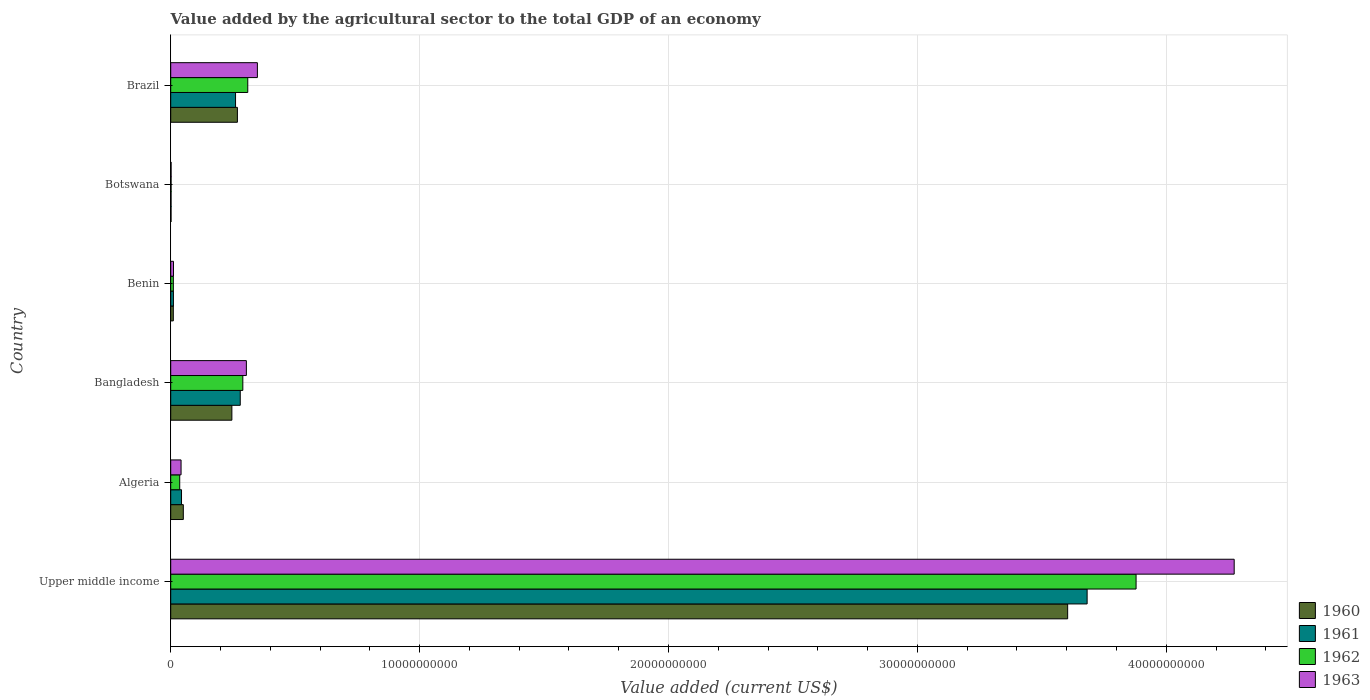How many different coloured bars are there?
Your answer should be very brief. 4. Are the number of bars on each tick of the Y-axis equal?
Keep it short and to the point. Yes. How many bars are there on the 6th tick from the top?
Your answer should be very brief. 4. How many bars are there on the 3rd tick from the bottom?
Give a very brief answer. 4. What is the label of the 5th group of bars from the top?
Your answer should be compact. Algeria. In how many cases, is the number of bars for a given country not equal to the number of legend labels?
Your answer should be compact. 0. What is the value added by the agricultural sector to the total GDP in 1960 in Benin?
Give a very brief answer. 1.04e+08. Across all countries, what is the maximum value added by the agricultural sector to the total GDP in 1963?
Offer a very short reply. 4.27e+1. Across all countries, what is the minimum value added by the agricultural sector to the total GDP in 1963?
Make the answer very short. 1.51e+07. In which country was the value added by the agricultural sector to the total GDP in 1963 maximum?
Provide a short and direct response. Upper middle income. In which country was the value added by the agricultural sector to the total GDP in 1960 minimum?
Give a very brief answer. Botswana. What is the total value added by the agricultural sector to the total GDP in 1961 in the graph?
Offer a very short reply. 4.28e+1. What is the difference between the value added by the agricultural sector to the total GDP in 1961 in Algeria and that in Brazil?
Give a very brief answer. -2.17e+09. What is the difference between the value added by the agricultural sector to the total GDP in 1960 in Brazil and the value added by the agricultural sector to the total GDP in 1961 in Benin?
Your answer should be compact. 2.57e+09. What is the average value added by the agricultural sector to the total GDP in 1961 per country?
Keep it short and to the point. 7.13e+09. What is the difference between the value added by the agricultural sector to the total GDP in 1961 and value added by the agricultural sector to the total GDP in 1962 in Brazil?
Offer a very short reply. -4.91e+08. In how many countries, is the value added by the agricultural sector to the total GDP in 1963 greater than 22000000000 US$?
Your answer should be very brief. 1. What is the ratio of the value added by the agricultural sector to the total GDP in 1961 in Brazil to that in Upper middle income?
Keep it short and to the point. 0.07. What is the difference between the highest and the second highest value added by the agricultural sector to the total GDP in 1960?
Provide a short and direct response. 3.34e+1. What is the difference between the highest and the lowest value added by the agricultural sector to the total GDP in 1962?
Make the answer very short. 3.88e+1. Is the sum of the value added by the agricultural sector to the total GDP in 1963 in Algeria and Brazil greater than the maximum value added by the agricultural sector to the total GDP in 1960 across all countries?
Your answer should be compact. No. Is it the case that in every country, the sum of the value added by the agricultural sector to the total GDP in 1960 and value added by the agricultural sector to the total GDP in 1962 is greater than the sum of value added by the agricultural sector to the total GDP in 1963 and value added by the agricultural sector to the total GDP in 1961?
Keep it short and to the point. No. What does the 3rd bar from the top in Algeria represents?
Provide a succinct answer. 1961. How many bars are there?
Provide a short and direct response. 24. Are all the bars in the graph horizontal?
Your answer should be compact. Yes. Does the graph contain any zero values?
Your response must be concise. No. How are the legend labels stacked?
Provide a short and direct response. Vertical. What is the title of the graph?
Your answer should be compact. Value added by the agricultural sector to the total GDP of an economy. Does "1980" appear as one of the legend labels in the graph?
Make the answer very short. No. What is the label or title of the X-axis?
Provide a short and direct response. Value added (current US$). What is the Value added (current US$) in 1960 in Upper middle income?
Provide a short and direct response. 3.60e+1. What is the Value added (current US$) in 1961 in Upper middle income?
Your response must be concise. 3.68e+1. What is the Value added (current US$) of 1962 in Upper middle income?
Keep it short and to the point. 3.88e+1. What is the Value added (current US$) in 1963 in Upper middle income?
Keep it short and to the point. 4.27e+1. What is the Value added (current US$) of 1960 in Algeria?
Ensure brevity in your answer.  5.06e+08. What is the Value added (current US$) in 1961 in Algeria?
Ensure brevity in your answer.  4.34e+08. What is the Value added (current US$) in 1962 in Algeria?
Offer a very short reply. 3.61e+08. What is the Value added (current US$) of 1963 in Algeria?
Provide a succinct answer. 4.16e+08. What is the Value added (current US$) of 1960 in Bangladesh?
Your answer should be very brief. 2.46e+09. What is the Value added (current US$) in 1961 in Bangladesh?
Provide a succinct answer. 2.79e+09. What is the Value added (current US$) in 1962 in Bangladesh?
Provide a short and direct response. 2.90e+09. What is the Value added (current US$) in 1963 in Bangladesh?
Make the answer very short. 3.04e+09. What is the Value added (current US$) of 1960 in Benin?
Offer a very short reply. 1.04e+08. What is the Value added (current US$) in 1961 in Benin?
Keep it short and to the point. 1.09e+08. What is the Value added (current US$) in 1962 in Benin?
Your answer should be very brief. 1.06e+08. What is the Value added (current US$) in 1963 in Benin?
Give a very brief answer. 1.11e+08. What is the Value added (current US$) in 1960 in Botswana?
Provide a short and direct response. 1.31e+07. What is the Value added (current US$) of 1961 in Botswana?
Make the answer very short. 1.38e+07. What is the Value added (current US$) of 1962 in Botswana?
Provide a succinct answer. 1.45e+07. What is the Value added (current US$) of 1963 in Botswana?
Your answer should be compact. 1.51e+07. What is the Value added (current US$) of 1960 in Brazil?
Keep it short and to the point. 2.68e+09. What is the Value added (current US$) of 1961 in Brazil?
Give a very brief answer. 2.60e+09. What is the Value added (current US$) of 1962 in Brazil?
Your response must be concise. 3.10e+09. What is the Value added (current US$) in 1963 in Brazil?
Provide a succinct answer. 3.48e+09. Across all countries, what is the maximum Value added (current US$) of 1960?
Make the answer very short. 3.60e+1. Across all countries, what is the maximum Value added (current US$) of 1961?
Your answer should be very brief. 3.68e+1. Across all countries, what is the maximum Value added (current US$) of 1962?
Ensure brevity in your answer.  3.88e+1. Across all countries, what is the maximum Value added (current US$) of 1963?
Offer a terse response. 4.27e+1. Across all countries, what is the minimum Value added (current US$) in 1960?
Offer a terse response. 1.31e+07. Across all countries, what is the minimum Value added (current US$) in 1961?
Offer a very short reply. 1.38e+07. Across all countries, what is the minimum Value added (current US$) in 1962?
Your answer should be compact. 1.45e+07. Across all countries, what is the minimum Value added (current US$) of 1963?
Keep it short and to the point. 1.51e+07. What is the total Value added (current US$) of 1960 in the graph?
Offer a terse response. 4.18e+1. What is the total Value added (current US$) in 1961 in the graph?
Offer a terse response. 4.28e+1. What is the total Value added (current US$) in 1962 in the graph?
Keep it short and to the point. 4.53e+1. What is the total Value added (current US$) in 1963 in the graph?
Ensure brevity in your answer.  4.98e+1. What is the difference between the Value added (current US$) in 1960 in Upper middle income and that in Algeria?
Offer a very short reply. 3.55e+1. What is the difference between the Value added (current US$) in 1961 in Upper middle income and that in Algeria?
Provide a short and direct response. 3.64e+1. What is the difference between the Value added (current US$) in 1962 in Upper middle income and that in Algeria?
Provide a succinct answer. 3.84e+1. What is the difference between the Value added (current US$) in 1963 in Upper middle income and that in Algeria?
Provide a short and direct response. 4.23e+1. What is the difference between the Value added (current US$) in 1960 in Upper middle income and that in Bangladesh?
Ensure brevity in your answer.  3.36e+1. What is the difference between the Value added (current US$) of 1961 in Upper middle income and that in Bangladesh?
Offer a terse response. 3.40e+1. What is the difference between the Value added (current US$) of 1962 in Upper middle income and that in Bangladesh?
Provide a short and direct response. 3.59e+1. What is the difference between the Value added (current US$) in 1963 in Upper middle income and that in Bangladesh?
Ensure brevity in your answer.  3.97e+1. What is the difference between the Value added (current US$) in 1960 in Upper middle income and that in Benin?
Your answer should be very brief. 3.59e+1. What is the difference between the Value added (current US$) in 1961 in Upper middle income and that in Benin?
Offer a terse response. 3.67e+1. What is the difference between the Value added (current US$) of 1962 in Upper middle income and that in Benin?
Provide a succinct answer. 3.87e+1. What is the difference between the Value added (current US$) of 1963 in Upper middle income and that in Benin?
Provide a succinct answer. 4.26e+1. What is the difference between the Value added (current US$) in 1960 in Upper middle income and that in Botswana?
Keep it short and to the point. 3.60e+1. What is the difference between the Value added (current US$) of 1961 in Upper middle income and that in Botswana?
Your answer should be very brief. 3.68e+1. What is the difference between the Value added (current US$) in 1962 in Upper middle income and that in Botswana?
Make the answer very short. 3.88e+1. What is the difference between the Value added (current US$) of 1963 in Upper middle income and that in Botswana?
Your answer should be very brief. 4.27e+1. What is the difference between the Value added (current US$) of 1960 in Upper middle income and that in Brazil?
Keep it short and to the point. 3.34e+1. What is the difference between the Value added (current US$) of 1961 in Upper middle income and that in Brazil?
Your response must be concise. 3.42e+1. What is the difference between the Value added (current US$) of 1962 in Upper middle income and that in Brazil?
Give a very brief answer. 3.57e+1. What is the difference between the Value added (current US$) of 1963 in Upper middle income and that in Brazil?
Offer a very short reply. 3.92e+1. What is the difference between the Value added (current US$) in 1960 in Algeria and that in Bangladesh?
Your answer should be very brief. -1.95e+09. What is the difference between the Value added (current US$) in 1961 in Algeria and that in Bangladesh?
Offer a terse response. -2.36e+09. What is the difference between the Value added (current US$) of 1962 in Algeria and that in Bangladesh?
Give a very brief answer. -2.54e+09. What is the difference between the Value added (current US$) in 1963 in Algeria and that in Bangladesh?
Your answer should be compact. -2.62e+09. What is the difference between the Value added (current US$) of 1960 in Algeria and that in Benin?
Make the answer very short. 4.02e+08. What is the difference between the Value added (current US$) in 1961 in Algeria and that in Benin?
Keep it short and to the point. 3.25e+08. What is the difference between the Value added (current US$) of 1962 in Algeria and that in Benin?
Make the answer very short. 2.56e+08. What is the difference between the Value added (current US$) in 1963 in Algeria and that in Benin?
Give a very brief answer. 3.05e+08. What is the difference between the Value added (current US$) of 1960 in Algeria and that in Botswana?
Ensure brevity in your answer.  4.93e+08. What is the difference between the Value added (current US$) in 1961 in Algeria and that in Botswana?
Keep it short and to the point. 4.20e+08. What is the difference between the Value added (current US$) of 1962 in Algeria and that in Botswana?
Offer a very short reply. 3.47e+08. What is the difference between the Value added (current US$) of 1963 in Algeria and that in Botswana?
Your answer should be very brief. 4.01e+08. What is the difference between the Value added (current US$) in 1960 in Algeria and that in Brazil?
Your answer should be very brief. -2.17e+09. What is the difference between the Value added (current US$) in 1961 in Algeria and that in Brazil?
Your response must be concise. -2.17e+09. What is the difference between the Value added (current US$) of 1962 in Algeria and that in Brazil?
Offer a very short reply. -2.73e+09. What is the difference between the Value added (current US$) in 1963 in Algeria and that in Brazil?
Offer a terse response. -3.07e+09. What is the difference between the Value added (current US$) of 1960 in Bangladesh and that in Benin?
Ensure brevity in your answer.  2.35e+09. What is the difference between the Value added (current US$) in 1961 in Bangladesh and that in Benin?
Keep it short and to the point. 2.68e+09. What is the difference between the Value added (current US$) in 1962 in Bangladesh and that in Benin?
Offer a terse response. 2.79e+09. What is the difference between the Value added (current US$) in 1963 in Bangladesh and that in Benin?
Ensure brevity in your answer.  2.93e+09. What is the difference between the Value added (current US$) of 1960 in Bangladesh and that in Botswana?
Ensure brevity in your answer.  2.44e+09. What is the difference between the Value added (current US$) in 1961 in Bangladesh and that in Botswana?
Give a very brief answer. 2.78e+09. What is the difference between the Value added (current US$) of 1962 in Bangladesh and that in Botswana?
Offer a terse response. 2.88e+09. What is the difference between the Value added (current US$) of 1963 in Bangladesh and that in Botswana?
Make the answer very short. 3.02e+09. What is the difference between the Value added (current US$) in 1960 in Bangladesh and that in Brazil?
Provide a succinct answer. -2.22e+08. What is the difference between the Value added (current US$) in 1961 in Bangladesh and that in Brazil?
Provide a succinct answer. 1.89e+08. What is the difference between the Value added (current US$) of 1962 in Bangladesh and that in Brazil?
Ensure brevity in your answer.  -1.98e+08. What is the difference between the Value added (current US$) in 1963 in Bangladesh and that in Brazil?
Ensure brevity in your answer.  -4.42e+08. What is the difference between the Value added (current US$) of 1960 in Benin and that in Botswana?
Provide a succinct answer. 9.13e+07. What is the difference between the Value added (current US$) in 1961 in Benin and that in Botswana?
Provide a succinct answer. 9.51e+07. What is the difference between the Value added (current US$) in 1962 in Benin and that in Botswana?
Give a very brief answer. 9.12e+07. What is the difference between the Value added (current US$) in 1963 in Benin and that in Botswana?
Offer a terse response. 9.59e+07. What is the difference between the Value added (current US$) in 1960 in Benin and that in Brazil?
Ensure brevity in your answer.  -2.57e+09. What is the difference between the Value added (current US$) in 1961 in Benin and that in Brazil?
Offer a very short reply. -2.50e+09. What is the difference between the Value added (current US$) of 1962 in Benin and that in Brazil?
Provide a succinct answer. -2.99e+09. What is the difference between the Value added (current US$) of 1963 in Benin and that in Brazil?
Give a very brief answer. -3.37e+09. What is the difference between the Value added (current US$) of 1960 in Botswana and that in Brazil?
Make the answer very short. -2.67e+09. What is the difference between the Value added (current US$) in 1961 in Botswana and that in Brazil?
Give a very brief answer. -2.59e+09. What is the difference between the Value added (current US$) in 1962 in Botswana and that in Brazil?
Keep it short and to the point. -3.08e+09. What is the difference between the Value added (current US$) of 1963 in Botswana and that in Brazil?
Your answer should be very brief. -3.47e+09. What is the difference between the Value added (current US$) of 1960 in Upper middle income and the Value added (current US$) of 1961 in Algeria?
Provide a succinct answer. 3.56e+1. What is the difference between the Value added (current US$) in 1960 in Upper middle income and the Value added (current US$) in 1962 in Algeria?
Provide a succinct answer. 3.57e+1. What is the difference between the Value added (current US$) of 1960 in Upper middle income and the Value added (current US$) of 1963 in Algeria?
Your response must be concise. 3.56e+1. What is the difference between the Value added (current US$) in 1961 in Upper middle income and the Value added (current US$) in 1962 in Algeria?
Your answer should be very brief. 3.65e+1. What is the difference between the Value added (current US$) of 1961 in Upper middle income and the Value added (current US$) of 1963 in Algeria?
Your answer should be very brief. 3.64e+1. What is the difference between the Value added (current US$) of 1962 in Upper middle income and the Value added (current US$) of 1963 in Algeria?
Keep it short and to the point. 3.84e+1. What is the difference between the Value added (current US$) of 1960 in Upper middle income and the Value added (current US$) of 1961 in Bangladesh?
Provide a succinct answer. 3.32e+1. What is the difference between the Value added (current US$) in 1960 in Upper middle income and the Value added (current US$) in 1962 in Bangladesh?
Offer a terse response. 3.31e+1. What is the difference between the Value added (current US$) of 1960 in Upper middle income and the Value added (current US$) of 1963 in Bangladesh?
Provide a succinct answer. 3.30e+1. What is the difference between the Value added (current US$) of 1961 in Upper middle income and the Value added (current US$) of 1962 in Bangladesh?
Offer a terse response. 3.39e+1. What is the difference between the Value added (current US$) in 1961 in Upper middle income and the Value added (current US$) in 1963 in Bangladesh?
Make the answer very short. 3.38e+1. What is the difference between the Value added (current US$) in 1962 in Upper middle income and the Value added (current US$) in 1963 in Bangladesh?
Your answer should be very brief. 3.57e+1. What is the difference between the Value added (current US$) in 1960 in Upper middle income and the Value added (current US$) in 1961 in Benin?
Your answer should be very brief. 3.59e+1. What is the difference between the Value added (current US$) in 1960 in Upper middle income and the Value added (current US$) in 1962 in Benin?
Make the answer very short. 3.59e+1. What is the difference between the Value added (current US$) in 1960 in Upper middle income and the Value added (current US$) in 1963 in Benin?
Your answer should be very brief. 3.59e+1. What is the difference between the Value added (current US$) of 1961 in Upper middle income and the Value added (current US$) of 1962 in Benin?
Give a very brief answer. 3.67e+1. What is the difference between the Value added (current US$) in 1961 in Upper middle income and the Value added (current US$) in 1963 in Benin?
Your answer should be very brief. 3.67e+1. What is the difference between the Value added (current US$) of 1962 in Upper middle income and the Value added (current US$) of 1963 in Benin?
Offer a very short reply. 3.87e+1. What is the difference between the Value added (current US$) of 1960 in Upper middle income and the Value added (current US$) of 1961 in Botswana?
Ensure brevity in your answer.  3.60e+1. What is the difference between the Value added (current US$) of 1960 in Upper middle income and the Value added (current US$) of 1962 in Botswana?
Keep it short and to the point. 3.60e+1. What is the difference between the Value added (current US$) in 1960 in Upper middle income and the Value added (current US$) in 1963 in Botswana?
Ensure brevity in your answer.  3.60e+1. What is the difference between the Value added (current US$) in 1961 in Upper middle income and the Value added (current US$) in 1962 in Botswana?
Provide a short and direct response. 3.68e+1. What is the difference between the Value added (current US$) of 1961 in Upper middle income and the Value added (current US$) of 1963 in Botswana?
Your answer should be very brief. 3.68e+1. What is the difference between the Value added (current US$) of 1962 in Upper middle income and the Value added (current US$) of 1963 in Botswana?
Give a very brief answer. 3.88e+1. What is the difference between the Value added (current US$) in 1960 in Upper middle income and the Value added (current US$) in 1961 in Brazil?
Provide a succinct answer. 3.34e+1. What is the difference between the Value added (current US$) in 1960 in Upper middle income and the Value added (current US$) in 1962 in Brazil?
Offer a very short reply. 3.29e+1. What is the difference between the Value added (current US$) in 1960 in Upper middle income and the Value added (current US$) in 1963 in Brazil?
Make the answer very short. 3.26e+1. What is the difference between the Value added (current US$) of 1961 in Upper middle income and the Value added (current US$) of 1962 in Brazil?
Your answer should be compact. 3.37e+1. What is the difference between the Value added (current US$) of 1961 in Upper middle income and the Value added (current US$) of 1963 in Brazil?
Offer a very short reply. 3.33e+1. What is the difference between the Value added (current US$) in 1962 in Upper middle income and the Value added (current US$) in 1963 in Brazil?
Provide a short and direct response. 3.53e+1. What is the difference between the Value added (current US$) of 1960 in Algeria and the Value added (current US$) of 1961 in Bangladesh?
Your answer should be very brief. -2.29e+09. What is the difference between the Value added (current US$) of 1960 in Algeria and the Value added (current US$) of 1962 in Bangladesh?
Provide a short and direct response. -2.39e+09. What is the difference between the Value added (current US$) of 1960 in Algeria and the Value added (current US$) of 1963 in Bangladesh?
Your answer should be compact. -2.53e+09. What is the difference between the Value added (current US$) in 1961 in Algeria and the Value added (current US$) in 1962 in Bangladesh?
Offer a terse response. -2.46e+09. What is the difference between the Value added (current US$) in 1961 in Algeria and the Value added (current US$) in 1963 in Bangladesh?
Give a very brief answer. -2.61e+09. What is the difference between the Value added (current US$) of 1962 in Algeria and the Value added (current US$) of 1963 in Bangladesh?
Provide a succinct answer. -2.68e+09. What is the difference between the Value added (current US$) of 1960 in Algeria and the Value added (current US$) of 1961 in Benin?
Offer a terse response. 3.97e+08. What is the difference between the Value added (current US$) of 1960 in Algeria and the Value added (current US$) of 1962 in Benin?
Provide a short and direct response. 4.00e+08. What is the difference between the Value added (current US$) in 1960 in Algeria and the Value added (current US$) in 1963 in Benin?
Ensure brevity in your answer.  3.95e+08. What is the difference between the Value added (current US$) in 1961 in Algeria and the Value added (current US$) in 1962 in Benin?
Make the answer very short. 3.28e+08. What is the difference between the Value added (current US$) of 1961 in Algeria and the Value added (current US$) of 1963 in Benin?
Your response must be concise. 3.23e+08. What is the difference between the Value added (current US$) of 1962 in Algeria and the Value added (current US$) of 1963 in Benin?
Make the answer very short. 2.50e+08. What is the difference between the Value added (current US$) of 1960 in Algeria and the Value added (current US$) of 1961 in Botswana?
Offer a very short reply. 4.92e+08. What is the difference between the Value added (current US$) of 1960 in Algeria and the Value added (current US$) of 1962 in Botswana?
Provide a short and direct response. 4.92e+08. What is the difference between the Value added (current US$) in 1960 in Algeria and the Value added (current US$) in 1963 in Botswana?
Make the answer very short. 4.91e+08. What is the difference between the Value added (current US$) of 1961 in Algeria and the Value added (current US$) of 1962 in Botswana?
Offer a terse response. 4.19e+08. What is the difference between the Value added (current US$) of 1961 in Algeria and the Value added (current US$) of 1963 in Botswana?
Give a very brief answer. 4.19e+08. What is the difference between the Value added (current US$) of 1962 in Algeria and the Value added (current US$) of 1963 in Botswana?
Provide a short and direct response. 3.46e+08. What is the difference between the Value added (current US$) in 1960 in Algeria and the Value added (current US$) in 1961 in Brazil?
Provide a succinct answer. -2.10e+09. What is the difference between the Value added (current US$) in 1960 in Algeria and the Value added (current US$) in 1962 in Brazil?
Give a very brief answer. -2.59e+09. What is the difference between the Value added (current US$) in 1960 in Algeria and the Value added (current US$) in 1963 in Brazil?
Ensure brevity in your answer.  -2.98e+09. What is the difference between the Value added (current US$) in 1961 in Algeria and the Value added (current US$) in 1962 in Brazil?
Make the answer very short. -2.66e+09. What is the difference between the Value added (current US$) in 1961 in Algeria and the Value added (current US$) in 1963 in Brazil?
Provide a succinct answer. -3.05e+09. What is the difference between the Value added (current US$) of 1962 in Algeria and the Value added (current US$) of 1963 in Brazil?
Provide a succinct answer. -3.12e+09. What is the difference between the Value added (current US$) of 1960 in Bangladesh and the Value added (current US$) of 1961 in Benin?
Give a very brief answer. 2.35e+09. What is the difference between the Value added (current US$) of 1960 in Bangladesh and the Value added (current US$) of 1962 in Benin?
Provide a succinct answer. 2.35e+09. What is the difference between the Value added (current US$) of 1960 in Bangladesh and the Value added (current US$) of 1963 in Benin?
Give a very brief answer. 2.35e+09. What is the difference between the Value added (current US$) in 1961 in Bangladesh and the Value added (current US$) in 1962 in Benin?
Give a very brief answer. 2.69e+09. What is the difference between the Value added (current US$) of 1961 in Bangladesh and the Value added (current US$) of 1963 in Benin?
Provide a short and direct response. 2.68e+09. What is the difference between the Value added (current US$) of 1962 in Bangladesh and the Value added (current US$) of 1963 in Benin?
Your response must be concise. 2.79e+09. What is the difference between the Value added (current US$) in 1960 in Bangladesh and the Value added (current US$) in 1961 in Botswana?
Your answer should be compact. 2.44e+09. What is the difference between the Value added (current US$) of 1960 in Bangladesh and the Value added (current US$) of 1962 in Botswana?
Your response must be concise. 2.44e+09. What is the difference between the Value added (current US$) in 1960 in Bangladesh and the Value added (current US$) in 1963 in Botswana?
Offer a very short reply. 2.44e+09. What is the difference between the Value added (current US$) of 1961 in Bangladesh and the Value added (current US$) of 1962 in Botswana?
Offer a terse response. 2.78e+09. What is the difference between the Value added (current US$) in 1961 in Bangladesh and the Value added (current US$) in 1963 in Botswana?
Offer a terse response. 2.78e+09. What is the difference between the Value added (current US$) in 1962 in Bangladesh and the Value added (current US$) in 1963 in Botswana?
Your answer should be compact. 2.88e+09. What is the difference between the Value added (current US$) in 1960 in Bangladesh and the Value added (current US$) in 1961 in Brazil?
Provide a short and direct response. -1.48e+08. What is the difference between the Value added (current US$) of 1960 in Bangladesh and the Value added (current US$) of 1962 in Brazil?
Provide a short and direct response. -6.39e+08. What is the difference between the Value added (current US$) of 1960 in Bangladesh and the Value added (current US$) of 1963 in Brazil?
Ensure brevity in your answer.  -1.03e+09. What is the difference between the Value added (current US$) of 1961 in Bangladesh and the Value added (current US$) of 1962 in Brazil?
Give a very brief answer. -3.02e+08. What is the difference between the Value added (current US$) of 1961 in Bangladesh and the Value added (current US$) of 1963 in Brazil?
Ensure brevity in your answer.  -6.89e+08. What is the difference between the Value added (current US$) in 1962 in Bangladesh and the Value added (current US$) in 1963 in Brazil?
Provide a short and direct response. -5.85e+08. What is the difference between the Value added (current US$) of 1960 in Benin and the Value added (current US$) of 1961 in Botswana?
Keep it short and to the point. 9.06e+07. What is the difference between the Value added (current US$) of 1960 in Benin and the Value added (current US$) of 1962 in Botswana?
Offer a terse response. 8.99e+07. What is the difference between the Value added (current US$) of 1960 in Benin and the Value added (current US$) of 1963 in Botswana?
Ensure brevity in your answer.  8.93e+07. What is the difference between the Value added (current US$) in 1961 in Benin and the Value added (current US$) in 1962 in Botswana?
Offer a terse response. 9.44e+07. What is the difference between the Value added (current US$) of 1961 in Benin and the Value added (current US$) of 1963 in Botswana?
Make the answer very short. 9.37e+07. What is the difference between the Value added (current US$) of 1962 in Benin and the Value added (current US$) of 1963 in Botswana?
Your response must be concise. 9.06e+07. What is the difference between the Value added (current US$) in 1960 in Benin and the Value added (current US$) in 1961 in Brazil?
Give a very brief answer. -2.50e+09. What is the difference between the Value added (current US$) in 1960 in Benin and the Value added (current US$) in 1962 in Brazil?
Your answer should be very brief. -2.99e+09. What is the difference between the Value added (current US$) in 1960 in Benin and the Value added (current US$) in 1963 in Brazil?
Your answer should be very brief. -3.38e+09. What is the difference between the Value added (current US$) of 1961 in Benin and the Value added (current US$) of 1962 in Brazil?
Your answer should be very brief. -2.99e+09. What is the difference between the Value added (current US$) in 1961 in Benin and the Value added (current US$) in 1963 in Brazil?
Give a very brief answer. -3.37e+09. What is the difference between the Value added (current US$) of 1962 in Benin and the Value added (current US$) of 1963 in Brazil?
Your answer should be very brief. -3.38e+09. What is the difference between the Value added (current US$) of 1960 in Botswana and the Value added (current US$) of 1961 in Brazil?
Your response must be concise. -2.59e+09. What is the difference between the Value added (current US$) of 1960 in Botswana and the Value added (current US$) of 1962 in Brazil?
Provide a succinct answer. -3.08e+09. What is the difference between the Value added (current US$) in 1960 in Botswana and the Value added (current US$) in 1963 in Brazil?
Make the answer very short. -3.47e+09. What is the difference between the Value added (current US$) of 1961 in Botswana and the Value added (current US$) of 1962 in Brazil?
Your response must be concise. -3.08e+09. What is the difference between the Value added (current US$) of 1961 in Botswana and the Value added (current US$) of 1963 in Brazil?
Your answer should be compact. -3.47e+09. What is the difference between the Value added (current US$) in 1962 in Botswana and the Value added (current US$) in 1963 in Brazil?
Your answer should be compact. -3.47e+09. What is the average Value added (current US$) of 1960 per country?
Make the answer very short. 6.97e+09. What is the average Value added (current US$) of 1961 per country?
Your response must be concise. 7.13e+09. What is the average Value added (current US$) in 1962 per country?
Your response must be concise. 7.54e+09. What is the average Value added (current US$) in 1963 per country?
Provide a succinct answer. 8.30e+09. What is the difference between the Value added (current US$) in 1960 and Value added (current US$) in 1961 in Upper middle income?
Make the answer very short. -7.82e+08. What is the difference between the Value added (current US$) in 1960 and Value added (current US$) in 1962 in Upper middle income?
Provide a short and direct response. -2.75e+09. What is the difference between the Value added (current US$) in 1960 and Value added (current US$) in 1963 in Upper middle income?
Your answer should be compact. -6.69e+09. What is the difference between the Value added (current US$) in 1961 and Value added (current US$) in 1962 in Upper middle income?
Your answer should be compact. -1.97e+09. What is the difference between the Value added (current US$) in 1961 and Value added (current US$) in 1963 in Upper middle income?
Ensure brevity in your answer.  -5.91e+09. What is the difference between the Value added (current US$) in 1962 and Value added (current US$) in 1963 in Upper middle income?
Your response must be concise. -3.94e+09. What is the difference between the Value added (current US$) of 1960 and Value added (current US$) of 1961 in Algeria?
Your response must be concise. 7.23e+07. What is the difference between the Value added (current US$) in 1960 and Value added (current US$) in 1962 in Algeria?
Ensure brevity in your answer.  1.45e+08. What is the difference between the Value added (current US$) in 1960 and Value added (current US$) in 1963 in Algeria?
Your answer should be very brief. 9.04e+07. What is the difference between the Value added (current US$) of 1961 and Value added (current US$) of 1962 in Algeria?
Offer a terse response. 7.23e+07. What is the difference between the Value added (current US$) in 1961 and Value added (current US$) in 1963 in Algeria?
Provide a short and direct response. 1.81e+07. What is the difference between the Value added (current US$) of 1962 and Value added (current US$) of 1963 in Algeria?
Ensure brevity in your answer.  -5.42e+07. What is the difference between the Value added (current US$) in 1960 and Value added (current US$) in 1961 in Bangladesh?
Offer a very short reply. -3.37e+08. What is the difference between the Value added (current US$) of 1960 and Value added (current US$) of 1962 in Bangladesh?
Provide a short and direct response. -4.40e+08. What is the difference between the Value added (current US$) in 1960 and Value added (current US$) in 1963 in Bangladesh?
Provide a short and direct response. -5.83e+08. What is the difference between the Value added (current US$) in 1961 and Value added (current US$) in 1962 in Bangladesh?
Offer a terse response. -1.04e+08. What is the difference between the Value added (current US$) in 1961 and Value added (current US$) in 1963 in Bangladesh?
Give a very brief answer. -2.46e+08. What is the difference between the Value added (current US$) in 1962 and Value added (current US$) in 1963 in Bangladesh?
Make the answer very short. -1.43e+08. What is the difference between the Value added (current US$) of 1960 and Value added (current US$) of 1961 in Benin?
Offer a terse response. -4.46e+06. What is the difference between the Value added (current US$) in 1960 and Value added (current US$) in 1962 in Benin?
Provide a succinct answer. -1.30e+06. What is the difference between the Value added (current US$) of 1960 and Value added (current US$) of 1963 in Benin?
Keep it short and to the point. -6.61e+06. What is the difference between the Value added (current US$) in 1961 and Value added (current US$) in 1962 in Benin?
Give a very brief answer. 3.16e+06. What is the difference between the Value added (current US$) in 1961 and Value added (current US$) in 1963 in Benin?
Your response must be concise. -2.15e+06. What is the difference between the Value added (current US$) of 1962 and Value added (current US$) of 1963 in Benin?
Your response must be concise. -5.30e+06. What is the difference between the Value added (current US$) of 1960 and Value added (current US$) of 1961 in Botswana?
Offer a terse response. -6.50e+05. What is the difference between the Value added (current US$) of 1960 and Value added (current US$) of 1962 in Botswana?
Make the answer very short. -1.35e+06. What is the difference between the Value added (current US$) in 1960 and Value added (current US$) in 1963 in Botswana?
Ensure brevity in your answer.  -1.99e+06. What is the difference between the Value added (current US$) of 1961 and Value added (current US$) of 1962 in Botswana?
Provide a short and direct response. -7.04e+05. What is the difference between the Value added (current US$) in 1961 and Value added (current US$) in 1963 in Botswana?
Ensure brevity in your answer.  -1.34e+06. What is the difference between the Value added (current US$) in 1962 and Value added (current US$) in 1963 in Botswana?
Keep it short and to the point. -6.34e+05. What is the difference between the Value added (current US$) in 1960 and Value added (current US$) in 1961 in Brazil?
Your response must be concise. 7.45e+07. What is the difference between the Value added (current US$) of 1960 and Value added (current US$) of 1962 in Brazil?
Your response must be concise. -4.16e+08. What is the difference between the Value added (current US$) of 1960 and Value added (current US$) of 1963 in Brazil?
Give a very brief answer. -8.03e+08. What is the difference between the Value added (current US$) of 1961 and Value added (current US$) of 1962 in Brazil?
Provide a succinct answer. -4.91e+08. What is the difference between the Value added (current US$) in 1961 and Value added (current US$) in 1963 in Brazil?
Make the answer very short. -8.77e+08. What is the difference between the Value added (current US$) in 1962 and Value added (current US$) in 1963 in Brazil?
Keep it short and to the point. -3.87e+08. What is the ratio of the Value added (current US$) of 1960 in Upper middle income to that in Algeria?
Keep it short and to the point. 71.21. What is the ratio of the Value added (current US$) of 1961 in Upper middle income to that in Algeria?
Offer a very short reply. 84.88. What is the ratio of the Value added (current US$) in 1962 in Upper middle income to that in Algeria?
Offer a very short reply. 107.3. What is the ratio of the Value added (current US$) in 1963 in Upper middle income to that in Algeria?
Make the answer very short. 102.79. What is the ratio of the Value added (current US$) of 1960 in Upper middle income to that in Bangladesh?
Your answer should be very brief. 14.67. What is the ratio of the Value added (current US$) of 1961 in Upper middle income to that in Bangladesh?
Keep it short and to the point. 13.18. What is the ratio of the Value added (current US$) of 1962 in Upper middle income to that in Bangladesh?
Offer a terse response. 13.39. What is the ratio of the Value added (current US$) of 1963 in Upper middle income to that in Bangladesh?
Provide a short and direct response. 14.06. What is the ratio of the Value added (current US$) in 1960 in Upper middle income to that in Benin?
Your answer should be compact. 345.17. What is the ratio of the Value added (current US$) in 1961 in Upper middle income to that in Benin?
Your answer should be compact. 338.22. What is the ratio of the Value added (current US$) of 1962 in Upper middle income to that in Benin?
Offer a very short reply. 366.93. What is the ratio of the Value added (current US$) of 1963 in Upper middle income to that in Benin?
Keep it short and to the point. 384.91. What is the ratio of the Value added (current US$) of 1960 in Upper middle income to that in Botswana?
Your response must be concise. 2741.64. What is the ratio of the Value added (current US$) in 1961 in Upper middle income to that in Botswana?
Make the answer very short. 2669.17. What is the ratio of the Value added (current US$) in 1962 in Upper middle income to that in Botswana?
Give a very brief answer. 2675.18. What is the ratio of the Value added (current US$) in 1963 in Upper middle income to that in Botswana?
Your response must be concise. 2823.66. What is the ratio of the Value added (current US$) of 1960 in Upper middle income to that in Brazil?
Offer a terse response. 13.45. What is the ratio of the Value added (current US$) in 1961 in Upper middle income to that in Brazil?
Keep it short and to the point. 14.14. What is the ratio of the Value added (current US$) in 1962 in Upper middle income to that in Brazil?
Ensure brevity in your answer.  12.53. What is the ratio of the Value added (current US$) of 1963 in Upper middle income to that in Brazil?
Ensure brevity in your answer.  12.27. What is the ratio of the Value added (current US$) of 1960 in Algeria to that in Bangladesh?
Your answer should be very brief. 0.21. What is the ratio of the Value added (current US$) of 1961 in Algeria to that in Bangladesh?
Ensure brevity in your answer.  0.16. What is the ratio of the Value added (current US$) of 1962 in Algeria to that in Bangladesh?
Ensure brevity in your answer.  0.12. What is the ratio of the Value added (current US$) in 1963 in Algeria to that in Bangladesh?
Offer a very short reply. 0.14. What is the ratio of the Value added (current US$) of 1960 in Algeria to that in Benin?
Your response must be concise. 4.85. What is the ratio of the Value added (current US$) in 1961 in Algeria to that in Benin?
Provide a succinct answer. 3.98. What is the ratio of the Value added (current US$) of 1962 in Algeria to that in Benin?
Your response must be concise. 3.42. What is the ratio of the Value added (current US$) in 1963 in Algeria to that in Benin?
Provide a succinct answer. 3.74. What is the ratio of the Value added (current US$) of 1960 in Algeria to that in Botswana?
Your response must be concise. 38.5. What is the ratio of the Value added (current US$) in 1961 in Algeria to that in Botswana?
Provide a succinct answer. 31.45. What is the ratio of the Value added (current US$) of 1962 in Algeria to that in Botswana?
Ensure brevity in your answer.  24.93. What is the ratio of the Value added (current US$) in 1963 in Algeria to that in Botswana?
Offer a terse response. 27.47. What is the ratio of the Value added (current US$) of 1960 in Algeria to that in Brazil?
Offer a terse response. 0.19. What is the ratio of the Value added (current US$) of 1961 in Algeria to that in Brazil?
Offer a terse response. 0.17. What is the ratio of the Value added (current US$) in 1962 in Algeria to that in Brazil?
Ensure brevity in your answer.  0.12. What is the ratio of the Value added (current US$) in 1963 in Algeria to that in Brazil?
Make the answer very short. 0.12. What is the ratio of the Value added (current US$) of 1960 in Bangladesh to that in Benin?
Offer a terse response. 23.53. What is the ratio of the Value added (current US$) of 1961 in Bangladesh to that in Benin?
Offer a very short reply. 25.66. What is the ratio of the Value added (current US$) of 1962 in Bangladesh to that in Benin?
Your answer should be very brief. 27.41. What is the ratio of the Value added (current US$) in 1963 in Bangladesh to that in Benin?
Your answer should be very brief. 27.38. What is the ratio of the Value added (current US$) of 1960 in Bangladesh to that in Botswana?
Make the answer very short. 186.92. What is the ratio of the Value added (current US$) of 1961 in Bangladesh to that in Botswana?
Make the answer very short. 202.51. What is the ratio of the Value added (current US$) in 1962 in Bangladesh to that in Botswana?
Your response must be concise. 199.83. What is the ratio of the Value added (current US$) in 1963 in Bangladesh to that in Botswana?
Your response must be concise. 200.88. What is the ratio of the Value added (current US$) of 1960 in Bangladesh to that in Brazil?
Make the answer very short. 0.92. What is the ratio of the Value added (current US$) in 1961 in Bangladesh to that in Brazil?
Ensure brevity in your answer.  1.07. What is the ratio of the Value added (current US$) of 1962 in Bangladesh to that in Brazil?
Ensure brevity in your answer.  0.94. What is the ratio of the Value added (current US$) in 1963 in Bangladesh to that in Brazil?
Offer a very short reply. 0.87. What is the ratio of the Value added (current US$) of 1960 in Benin to that in Botswana?
Give a very brief answer. 7.94. What is the ratio of the Value added (current US$) in 1961 in Benin to that in Botswana?
Provide a short and direct response. 7.89. What is the ratio of the Value added (current US$) of 1962 in Benin to that in Botswana?
Make the answer very short. 7.29. What is the ratio of the Value added (current US$) of 1963 in Benin to that in Botswana?
Make the answer very short. 7.34. What is the ratio of the Value added (current US$) in 1960 in Benin to that in Brazil?
Keep it short and to the point. 0.04. What is the ratio of the Value added (current US$) of 1961 in Benin to that in Brazil?
Provide a succinct answer. 0.04. What is the ratio of the Value added (current US$) in 1962 in Benin to that in Brazil?
Provide a succinct answer. 0.03. What is the ratio of the Value added (current US$) in 1963 in Benin to that in Brazil?
Provide a succinct answer. 0.03. What is the ratio of the Value added (current US$) of 1960 in Botswana to that in Brazil?
Ensure brevity in your answer.  0. What is the ratio of the Value added (current US$) in 1961 in Botswana to that in Brazil?
Ensure brevity in your answer.  0.01. What is the ratio of the Value added (current US$) of 1962 in Botswana to that in Brazil?
Provide a succinct answer. 0. What is the ratio of the Value added (current US$) in 1963 in Botswana to that in Brazil?
Provide a succinct answer. 0. What is the difference between the highest and the second highest Value added (current US$) of 1960?
Provide a succinct answer. 3.34e+1. What is the difference between the highest and the second highest Value added (current US$) in 1961?
Give a very brief answer. 3.40e+1. What is the difference between the highest and the second highest Value added (current US$) in 1962?
Keep it short and to the point. 3.57e+1. What is the difference between the highest and the second highest Value added (current US$) of 1963?
Your answer should be very brief. 3.92e+1. What is the difference between the highest and the lowest Value added (current US$) in 1960?
Offer a terse response. 3.60e+1. What is the difference between the highest and the lowest Value added (current US$) of 1961?
Offer a terse response. 3.68e+1. What is the difference between the highest and the lowest Value added (current US$) in 1962?
Offer a very short reply. 3.88e+1. What is the difference between the highest and the lowest Value added (current US$) in 1963?
Provide a succinct answer. 4.27e+1. 